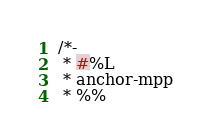<code> <loc_0><loc_0><loc_500><loc_500><_Java_>/*-
 * #%L
 * anchor-mpp
 * %%</code> 